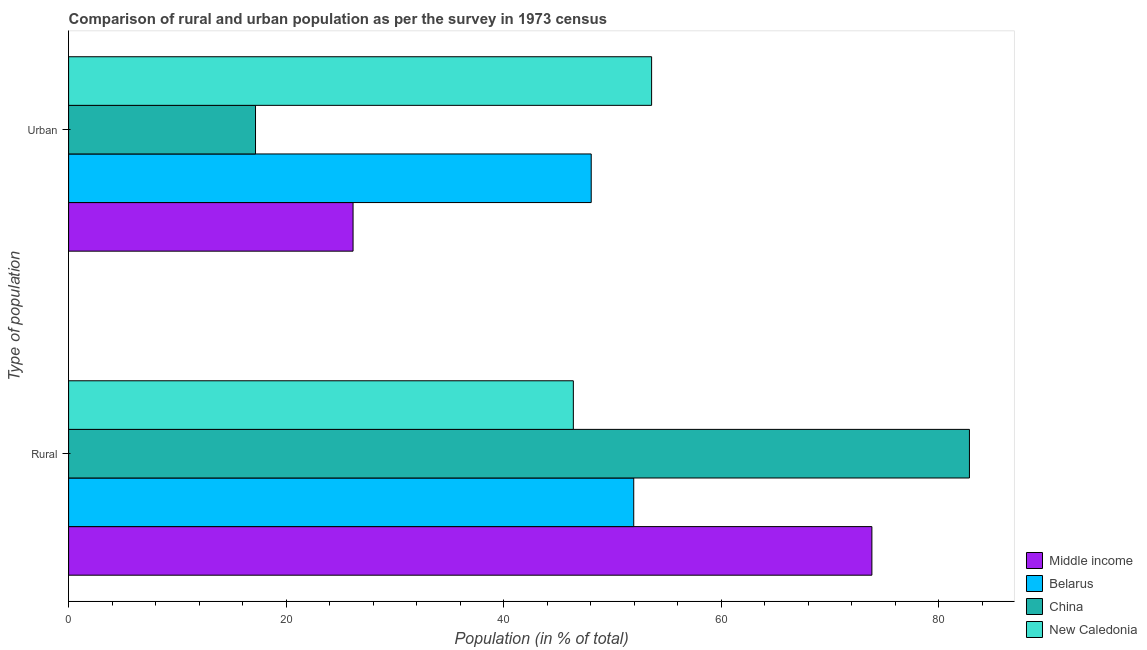Are the number of bars per tick equal to the number of legend labels?
Your response must be concise. Yes. How many bars are there on the 2nd tick from the top?
Your answer should be compact. 4. How many bars are there on the 2nd tick from the bottom?
Offer a very short reply. 4. What is the label of the 2nd group of bars from the top?
Offer a very short reply. Rural. What is the urban population in China?
Your answer should be very brief. 17.18. Across all countries, what is the maximum urban population?
Give a very brief answer. 53.6. Across all countries, what is the minimum urban population?
Offer a very short reply. 17.18. In which country was the rural population minimum?
Offer a terse response. New Caledonia. What is the total rural population in the graph?
Ensure brevity in your answer.  255.02. What is the difference between the urban population in China and that in Middle income?
Your answer should be compact. -8.97. What is the difference between the urban population in China and the rural population in Middle income?
Ensure brevity in your answer.  -56.67. What is the average urban population per country?
Provide a short and direct response. 36.24. What is the difference between the rural population and urban population in Belarus?
Offer a very short reply. 3.91. What is the ratio of the rural population in Middle income to that in New Caledonia?
Your answer should be compact. 1.59. Is the rural population in Middle income less than that in China?
Offer a very short reply. Yes. What does the 3rd bar from the top in Urban represents?
Offer a terse response. Belarus. What does the 2nd bar from the bottom in Urban represents?
Your response must be concise. Belarus. How many countries are there in the graph?
Your answer should be compact. 4. What is the difference between two consecutive major ticks on the X-axis?
Your response must be concise. 20. Are the values on the major ticks of X-axis written in scientific E-notation?
Ensure brevity in your answer.  No. Does the graph contain any zero values?
Ensure brevity in your answer.  No. Does the graph contain grids?
Your response must be concise. No. Where does the legend appear in the graph?
Your answer should be compact. Bottom right. How are the legend labels stacked?
Give a very brief answer. Vertical. What is the title of the graph?
Offer a terse response. Comparison of rural and urban population as per the survey in 1973 census. Does "Botswana" appear as one of the legend labels in the graph?
Your answer should be compact. No. What is the label or title of the X-axis?
Offer a terse response. Population (in % of total). What is the label or title of the Y-axis?
Offer a very short reply. Type of population. What is the Population (in % of total) of Middle income in Rural?
Your answer should be compact. 73.85. What is the Population (in % of total) of Belarus in Rural?
Ensure brevity in your answer.  51.95. What is the Population (in % of total) of China in Rural?
Offer a terse response. 82.82. What is the Population (in % of total) of New Caledonia in Rural?
Ensure brevity in your answer.  46.4. What is the Population (in % of total) of Middle income in Urban?
Give a very brief answer. 26.15. What is the Population (in % of total) of Belarus in Urban?
Your response must be concise. 48.05. What is the Population (in % of total) in China in Urban?
Offer a terse response. 17.18. What is the Population (in % of total) in New Caledonia in Urban?
Offer a terse response. 53.6. Across all Type of population, what is the maximum Population (in % of total) in Middle income?
Ensure brevity in your answer.  73.85. Across all Type of population, what is the maximum Population (in % of total) in Belarus?
Give a very brief answer. 51.95. Across all Type of population, what is the maximum Population (in % of total) of China?
Provide a succinct answer. 82.82. Across all Type of population, what is the maximum Population (in % of total) of New Caledonia?
Offer a terse response. 53.6. Across all Type of population, what is the minimum Population (in % of total) of Middle income?
Your answer should be compact. 26.15. Across all Type of population, what is the minimum Population (in % of total) in Belarus?
Ensure brevity in your answer.  48.05. Across all Type of population, what is the minimum Population (in % of total) of China?
Your answer should be compact. 17.18. Across all Type of population, what is the minimum Population (in % of total) in New Caledonia?
Keep it short and to the point. 46.4. What is the total Population (in % of total) in Middle income in the graph?
Ensure brevity in your answer.  100. What is the total Population (in % of total) of China in the graph?
Offer a terse response. 100. What is the difference between the Population (in % of total) of Middle income in Rural and that in Urban?
Make the answer very short. 47.7. What is the difference between the Population (in % of total) in Belarus in Rural and that in Urban?
Provide a short and direct response. 3.91. What is the difference between the Population (in % of total) in China in Rural and that in Urban?
Your answer should be very brief. 65.63. What is the difference between the Population (in % of total) of New Caledonia in Rural and that in Urban?
Provide a succinct answer. -7.19. What is the difference between the Population (in % of total) of Middle income in Rural and the Population (in % of total) of Belarus in Urban?
Make the answer very short. 25.8. What is the difference between the Population (in % of total) in Middle income in Rural and the Population (in % of total) in China in Urban?
Your answer should be very brief. 56.67. What is the difference between the Population (in % of total) in Middle income in Rural and the Population (in % of total) in New Caledonia in Urban?
Keep it short and to the point. 20.25. What is the difference between the Population (in % of total) of Belarus in Rural and the Population (in % of total) of China in Urban?
Give a very brief answer. 34.77. What is the difference between the Population (in % of total) in Belarus in Rural and the Population (in % of total) in New Caledonia in Urban?
Provide a succinct answer. -1.64. What is the difference between the Population (in % of total) in China in Rural and the Population (in % of total) in New Caledonia in Urban?
Provide a short and direct response. 29.22. What is the average Population (in % of total) of Middle income per Type of population?
Provide a short and direct response. 50. What is the difference between the Population (in % of total) of Middle income and Population (in % of total) of Belarus in Rural?
Provide a short and direct response. 21.9. What is the difference between the Population (in % of total) of Middle income and Population (in % of total) of China in Rural?
Offer a very short reply. -8.97. What is the difference between the Population (in % of total) of Middle income and Population (in % of total) of New Caledonia in Rural?
Your answer should be compact. 27.45. What is the difference between the Population (in % of total) of Belarus and Population (in % of total) of China in Rural?
Your response must be concise. -30.86. What is the difference between the Population (in % of total) in Belarus and Population (in % of total) in New Caledonia in Rural?
Ensure brevity in your answer.  5.55. What is the difference between the Population (in % of total) in China and Population (in % of total) in New Caledonia in Rural?
Your response must be concise. 36.41. What is the difference between the Population (in % of total) in Middle income and Population (in % of total) in Belarus in Urban?
Offer a very short reply. -21.9. What is the difference between the Population (in % of total) of Middle income and Population (in % of total) of China in Urban?
Your response must be concise. 8.97. What is the difference between the Population (in % of total) of Middle income and Population (in % of total) of New Caledonia in Urban?
Your answer should be very brief. -27.45. What is the difference between the Population (in % of total) of Belarus and Population (in % of total) of China in Urban?
Your answer should be compact. 30.86. What is the difference between the Population (in % of total) in Belarus and Population (in % of total) in New Caledonia in Urban?
Make the answer very short. -5.55. What is the difference between the Population (in % of total) in China and Population (in % of total) in New Caledonia in Urban?
Your answer should be compact. -36.41. What is the ratio of the Population (in % of total) in Middle income in Rural to that in Urban?
Your response must be concise. 2.82. What is the ratio of the Population (in % of total) of Belarus in Rural to that in Urban?
Give a very brief answer. 1.08. What is the ratio of the Population (in % of total) in China in Rural to that in Urban?
Your answer should be very brief. 4.82. What is the ratio of the Population (in % of total) in New Caledonia in Rural to that in Urban?
Make the answer very short. 0.87. What is the difference between the highest and the second highest Population (in % of total) in Middle income?
Ensure brevity in your answer.  47.7. What is the difference between the highest and the second highest Population (in % of total) of Belarus?
Keep it short and to the point. 3.91. What is the difference between the highest and the second highest Population (in % of total) of China?
Provide a succinct answer. 65.63. What is the difference between the highest and the second highest Population (in % of total) in New Caledonia?
Keep it short and to the point. 7.19. What is the difference between the highest and the lowest Population (in % of total) of Middle income?
Make the answer very short. 47.7. What is the difference between the highest and the lowest Population (in % of total) in Belarus?
Ensure brevity in your answer.  3.91. What is the difference between the highest and the lowest Population (in % of total) of China?
Your answer should be compact. 65.63. What is the difference between the highest and the lowest Population (in % of total) of New Caledonia?
Your answer should be compact. 7.19. 